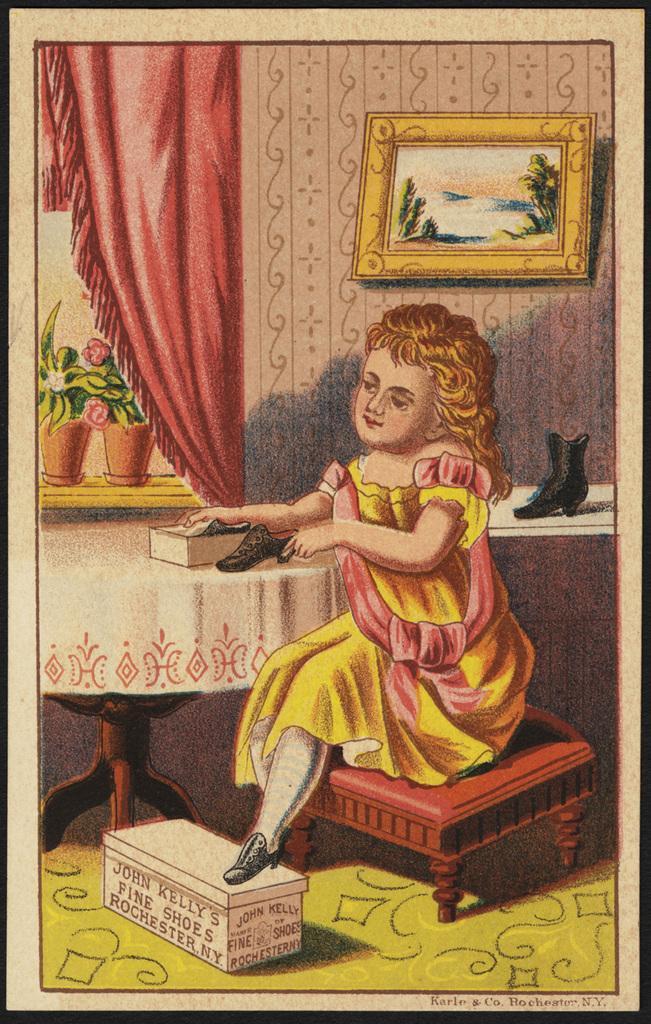Please provide a concise description of this image. In the picture we can see a painting of a girl child sitting on the stool and keeping her leg on the box and near to her we can see a table with a tablecloth and on it we can see a box with a shoe and the girl is holding another shoe in the hand, in the background, we can see a wall with a photo frame and beside it, we can see a window and some plants and curtain to the window which is red in color and under the photo frame we can see another table on it we can see a shoe. 